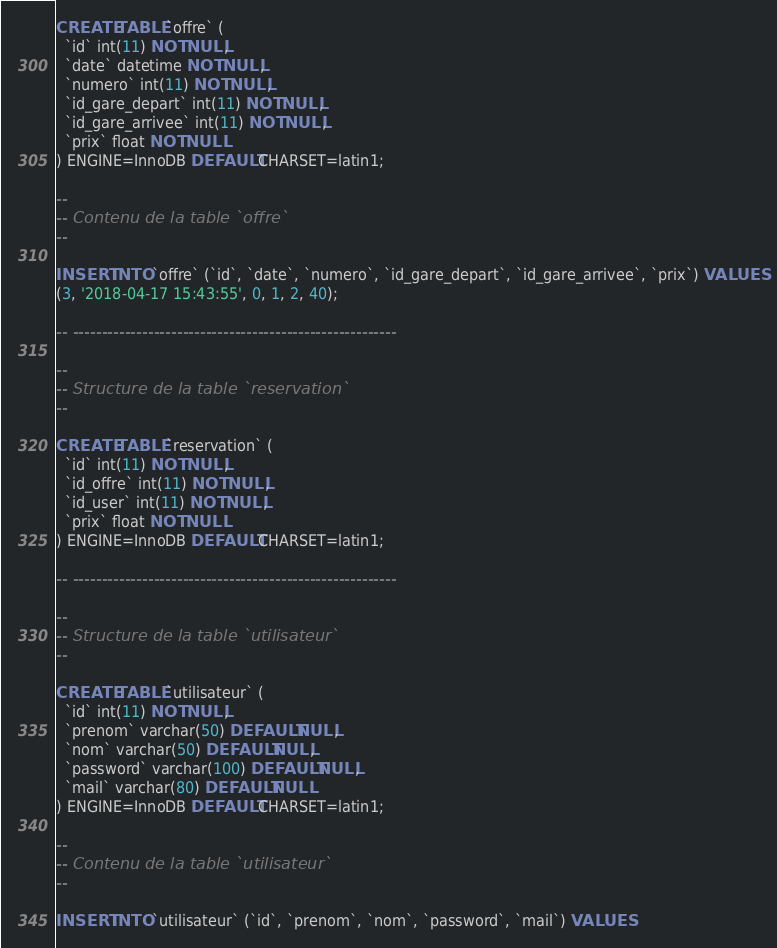Convert code to text. <code><loc_0><loc_0><loc_500><loc_500><_SQL_>
CREATE TABLE `offre` (
  `id` int(11) NOT NULL,
  `date` datetime NOT NULL,
  `numero` int(11) NOT NULL,
  `id_gare_depart` int(11) NOT NULL,
  `id_gare_arrivee` int(11) NOT NULL,
  `prix` float NOT NULL
) ENGINE=InnoDB DEFAULT CHARSET=latin1;

--
-- Contenu de la table `offre`
--

INSERT INTO `offre` (`id`, `date`, `numero`, `id_gare_depart`, `id_gare_arrivee`, `prix`) VALUES
(3, '2018-04-17 15:43:55', 0, 1, 2, 40);

-- --------------------------------------------------------

--
-- Structure de la table `reservation`
--

CREATE TABLE `reservation` (
  `id` int(11) NOT NULL,
  `id_offre` int(11) NOT NULL,
  `id_user` int(11) NOT NULL,
  `prix` float NOT NULL
) ENGINE=InnoDB DEFAULT CHARSET=latin1;

-- --------------------------------------------------------

--
-- Structure de la table `utilisateur`
--

CREATE TABLE `utilisateur` (
  `id` int(11) NOT NULL,
  `prenom` varchar(50) DEFAULT NULL,
  `nom` varchar(50) DEFAULT NULL,
  `password` varchar(100) DEFAULT NULL,
  `mail` varchar(80) DEFAULT NULL
) ENGINE=InnoDB DEFAULT CHARSET=latin1;

--
-- Contenu de la table `utilisateur`
--

INSERT INTO `utilisateur` (`id`, `prenom`, `nom`, `password`, `mail`) VALUES</code> 